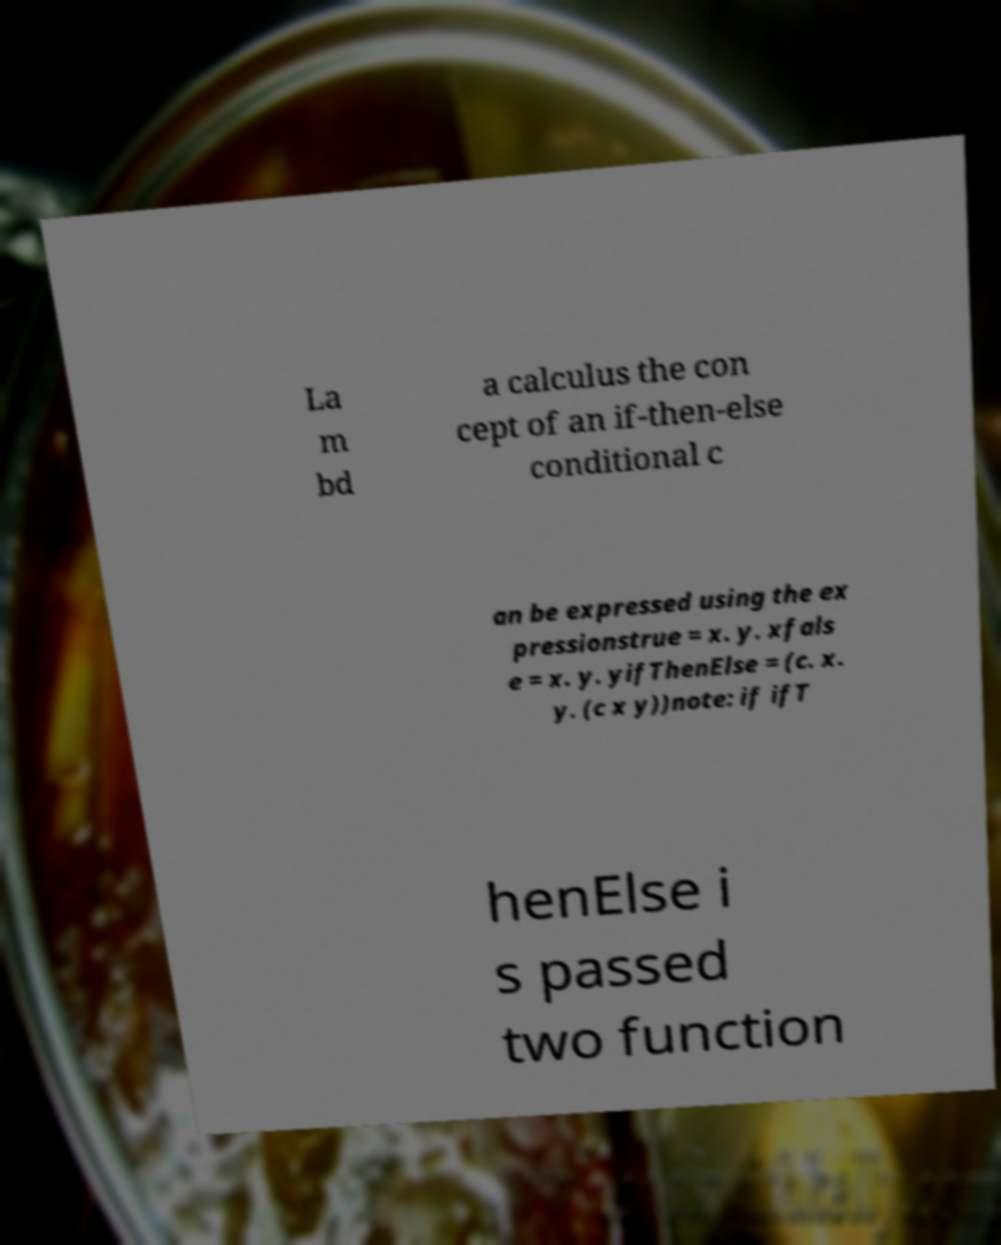Please identify and transcribe the text found in this image. La m bd a calculus the con cept of an if-then-else conditional c an be expressed using the ex pressionstrue = x. y. xfals e = x. y. yifThenElse = (c. x. y. (c x y))note: if ifT henElse i s passed two function 